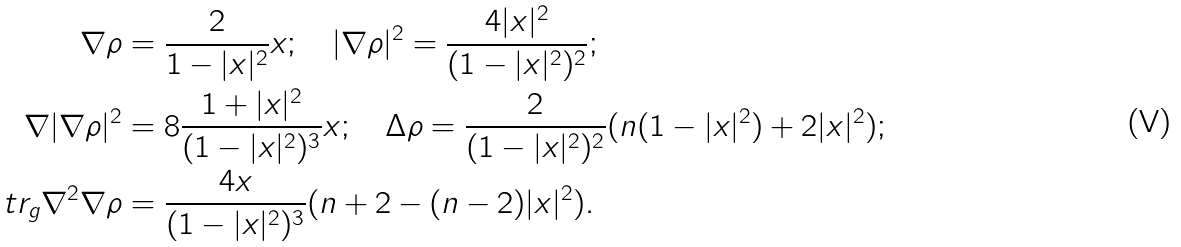<formula> <loc_0><loc_0><loc_500><loc_500>\nabla \rho & = \frac { 2 } { 1 - | x | ^ { 2 } } x ; \quad | \nabla \rho | ^ { 2 } = \frac { 4 | x | ^ { 2 } } { ( 1 - | x | ^ { 2 } ) ^ { 2 } } ; \\ \nabla | \nabla \rho | ^ { 2 } & = 8 \frac { 1 + | x | ^ { 2 } } { ( 1 - | x | ^ { 2 } ) ^ { 3 } } x ; \quad \Delta \rho = \frac { 2 } { ( 1 - | x | ^ { 2 } ) ^ { 2 } } ( n ( 1 - | x | ^ { 2 } ) + 2 | x | ^ { 2 } ) ; \\ \ t r _ { g } \nabla ^ { 2 } \nabla \rho & = \frac { 4 x } { ( 1 - | x | ^ { 2 } ) ^ { 3 } } ( n + 2 - ( n - 2 ) | x | ^ { 2 } ) .</formula> 